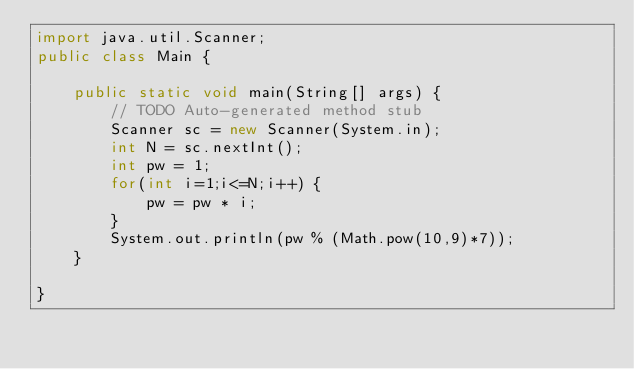Convert code to text. <code><loc_0><loc_0><loc_500><loc_500><_Java_>import java.util.Scanner;
public class Main {

	public static void main(String[] args) {
		// TODO Auto-generated method stub
		Scanner sc = new Scanner(System.in);
		int N = sc.nextInt();
		int pw = 1;
		for(int i=1;i<=N;i++) {
			pw = pw * i;
		}
		System.out.println(pw % (Math.pow(10,9)*7));
	}

}</code> 